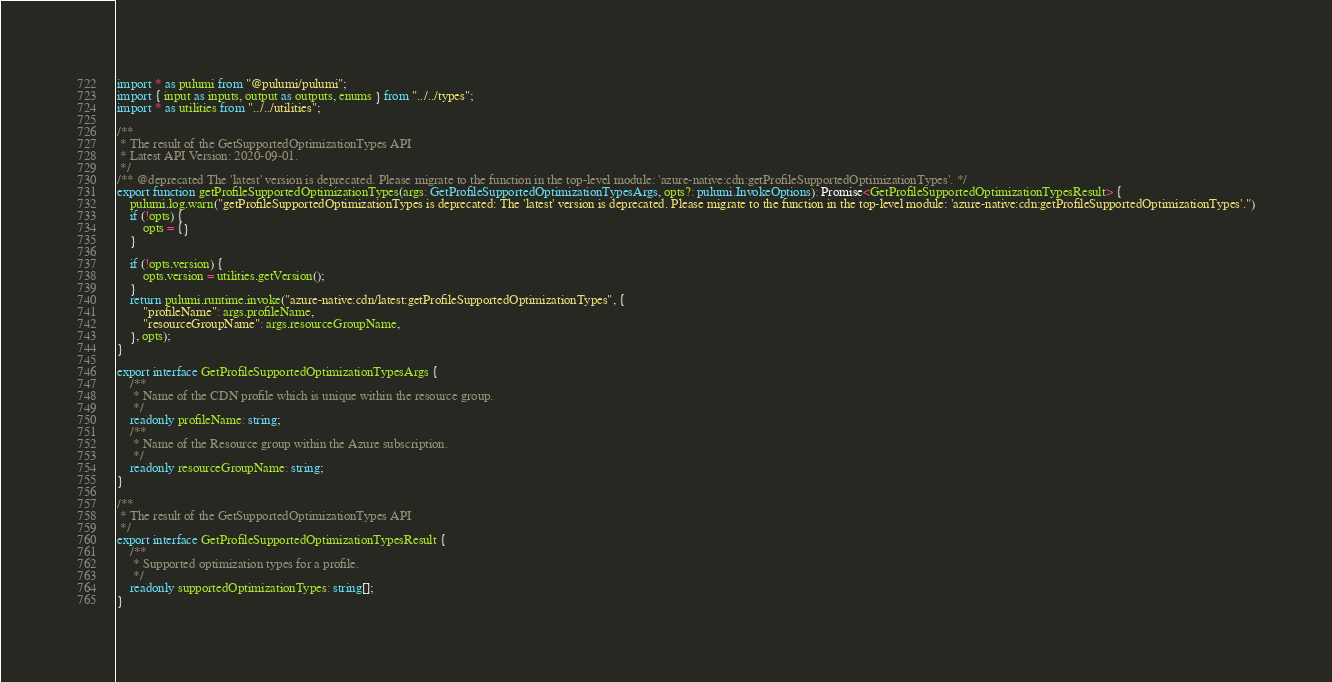<code> <loc_0><loc_0><loc_500><loc_500><_TypeScript_>
import * as pulumi from "@pulumi/pulumi";
import { input as inputs, output as outputs, enums } from "../../types";
import * as utilities from "../../utilities";

/**
 * The result of the GetSupportedOptimizationTypes API
 * Latest API Version: 2020-09-01.
 */
/** @deprecated The 'latest' version is deprecated. Please migrate to the function in the top-level module: 'azure-native:cdn:getProfileSupportedOptimizationTypes'. */
export function getProfileSupportedOptimizationTypes(args: GetProfileSupportedOptimizationTypesArgs, opts?: pulumi.InvokeOptions): Promise<GetProfileSupportedOptimizationTypesResult> {
    pulumi.log.warn("getProfileSupportedOptimizationTypes is deprecated: The 'latest' version is deprecated. Please migrate to the function in the top-level module: 'azure-native:cdn:getProfileSupportedOptimizationTypes'.")
    if (!opts) {
        opts = {}
    }

    if (!opts.version) {
        opts.version = utilities.getVersion();
    }
    return pulumi.runtime.invoke("azure-native:cdn/latest:getProfileSupportedOptimizationTypes", {
        "profileName": args.profileName,
        "resourceGroupName": args.resourceGroupName,
    }, opts);
}

export interface GetProfileSupportedOptimizationTypesArgs {
    /**
     * Name of the CDN profile which is unique within the resource group.
     */
    readonly profileName: string;
    /**
     * Name of the Resource group within the Azure subscription.
     */
    readonly resourceGroupName: string;
}

/**
 * The result of the GetSupportedOptimizationTypes API
 */
export interface GetProfileSupportedOptimizationTypesResult {
    /**
     * Supported optimization types for a profile.
     */
    readonly supportedOptimizationTypes: string[];
}
</code> 